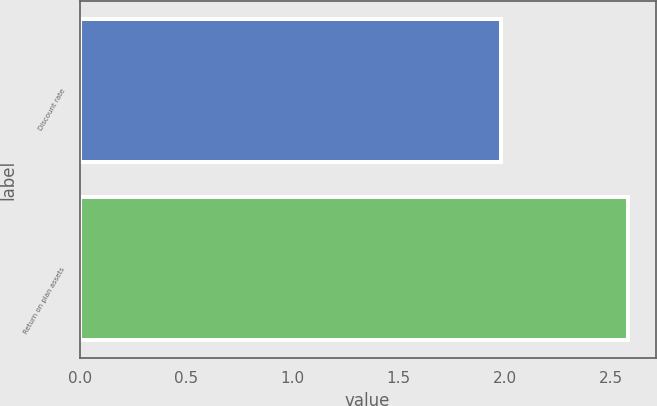<chart> <loc_0><loc_0><loc_500><loc_500><bar_chart><fcel>Discount rate<fcel>Return on plan assets<nl><fcel>1.98<fcel>2.58<nl></chart> 